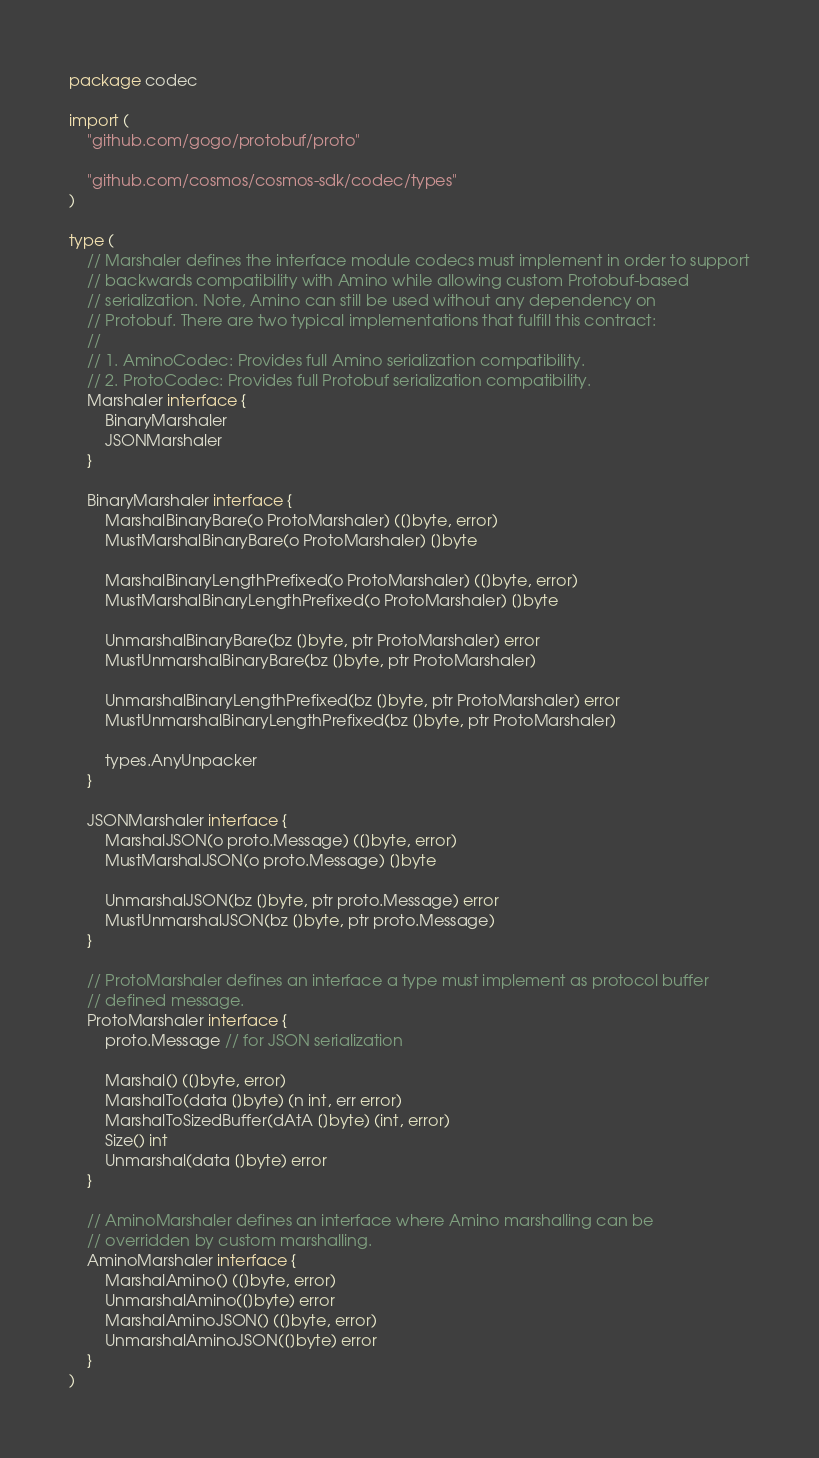Convert code to text. <code><loc_0><loc_0><loc_500><loc_500><_Go_>package codec

import (
	"github.com/gogo/protobuf/proto"

	"github.com/cosmos/cosmos-sdk/codec/types"
)

type (
	// Marshaler defines the interface module codecs must implement in order to support
	// backwards compatibility with Amino while allowing custom Protobuf-based
	// serialization. Note, Amino can still be used without any dependency on
	// Protobuf. There are two typical implementations that fulfill this contract:
	//
	// 1. AminoCodec: Provides full Amino serialization compatibility.
	// 2. ProtoCodec: Provides full Protobuf serialization compatibility.
	Marshaler interface {
		BinaryMarshaler
		JSONMarshaler
	}

	BinaryMarshaler interface {
		MarshalBinaryBare(o ProtoMarshaler) ([]byte, error)
		MustMarshalBinaryBare(o ProtoMarshaler) []byte

		MarshalBinaryLengthPrefixed(o ProtoMarshaler) ([]byte, error)
		MustMarshalBinaryLengthPrefixed(o ProtoMarshaler) []byte

		UnmarshalBinaryBare(bz []byte, ptr ProtoMarshaler) error
		MustUnmarshalBinaryBare(bz []byte, ptr ProtoMarshaler)

		UnmarshalBinaryLengthPrefixed(bz []byte, ptr ProtoMarshaler) error
		MustUnmarshalBinaryLengthPrefixed(bz []byte, ptr ProtoMarshaler)

		types.AnyUnpacker
	}

	JSONMarshaler interface {
		MarshalJSON(o proto.Message) ([]byte, error)
		MustMarshalJSON(o proto.Message) []byte

		UnmarshalJSON(bz []byte, ptr proto.Message) error
		MustUnmarshalJSON(bz []byte, ptr proto.Message)
	}

	// ProtoMarshaler defines an interface a type must implement as protocol buffer
	// defined message.
	ProtoMarshaler interface {
		proto.Message // for JSON serialization

		Marshal() ([]byte, error)
		MarshalTo(data []byte) (n int, err error)
		MarshalToSizedBuffer(dAtA []byte) (int, error)
		Size() int
		Unmarshal(data []byte) error
	}

	// AminoMarshaler defines an interface where Amino marshalling can be
	// overridden by custom marshalling.
	AminoMarshaler interface {
		MarshalAmino() ([]byte, error)
		UnmarshalAmino([]byte) error
		MarshalAminoJSON() ([]byte, error)
		UnmarshalAminoJSON([]byte) error
	}
)
</code> 